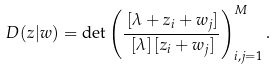<formula> <loc_0><loc_0><loc_500><loc_500>D ( z | w ) = \det \left ( \frac { \, [ \lambda + z _ { i } + w _ { j } ] } { \, [ \lambda ] \, [ z _ { i } + w _ { j } ] } \right ) _ { i , j = 1 } ^ { M } .</formula> 